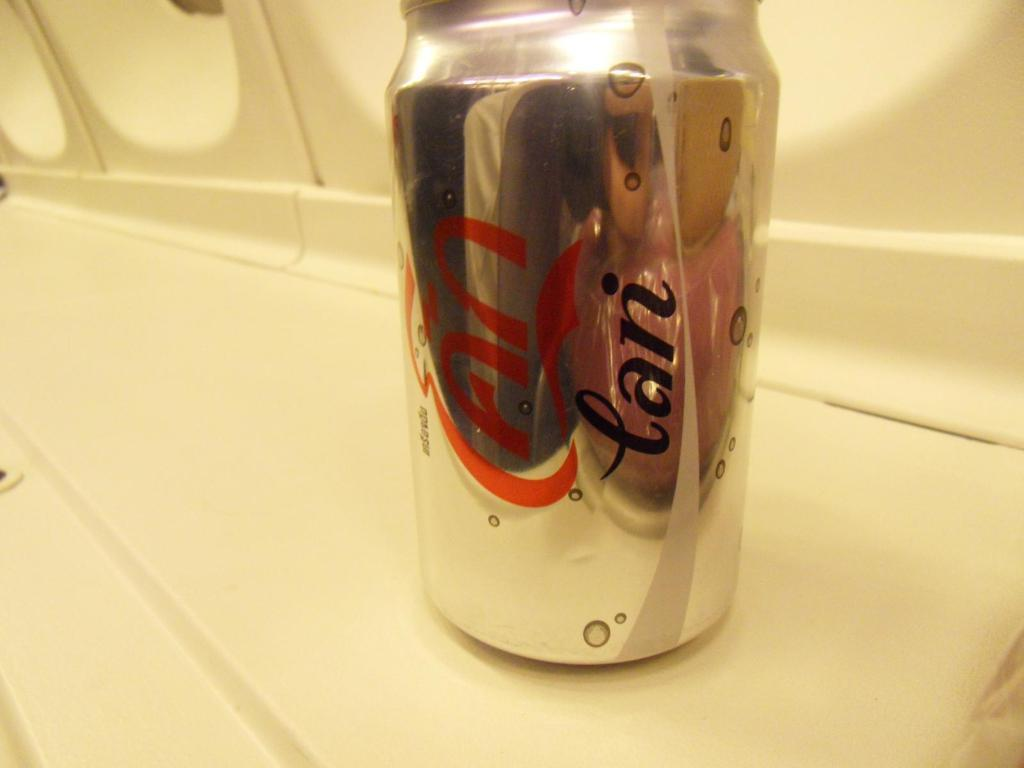<image>
Describe the image concisely. A can of soda with foreign writing in red and black on it. 